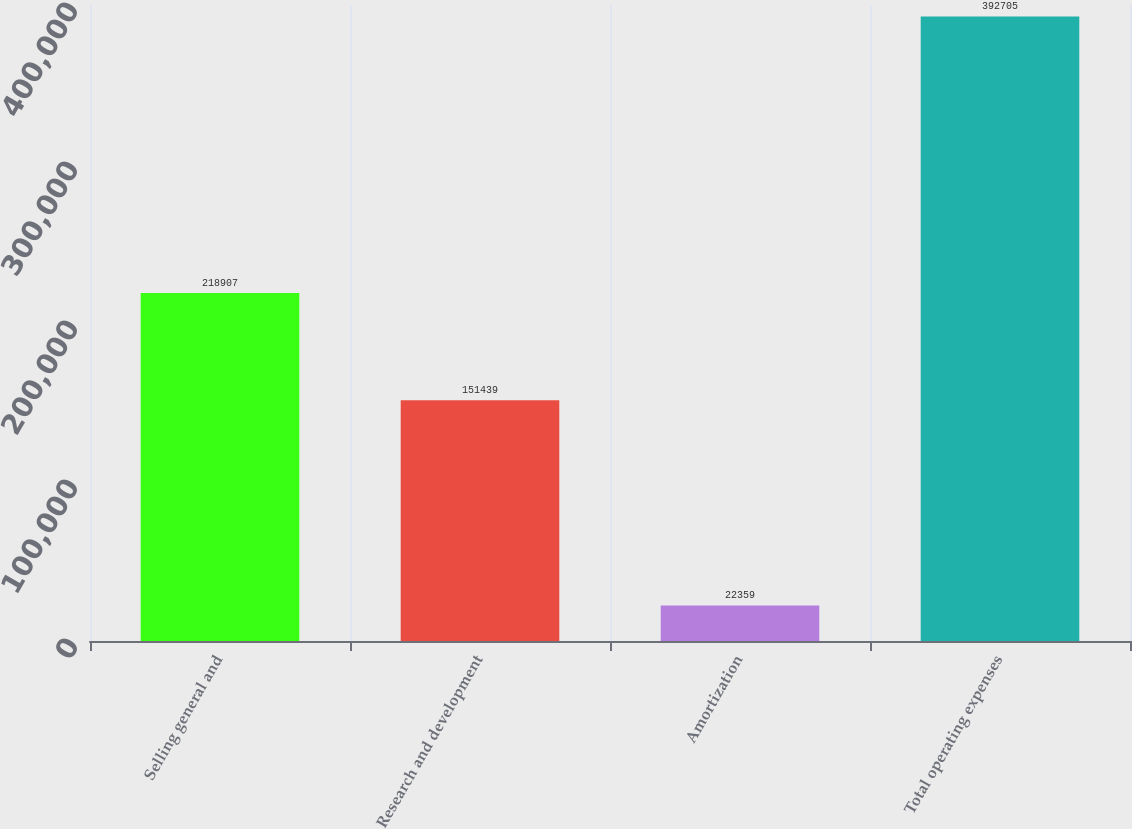<chart> <loc_0><loc_0><loc_500><loc_500><bar_chart><fcel>Selling general and<fcel>Research and development<fcel>Amortization<fcel>Total operating expenses<nl><fcel>218907<fcel>151439<fcel>22359<fcel>392705<nl></chart> 